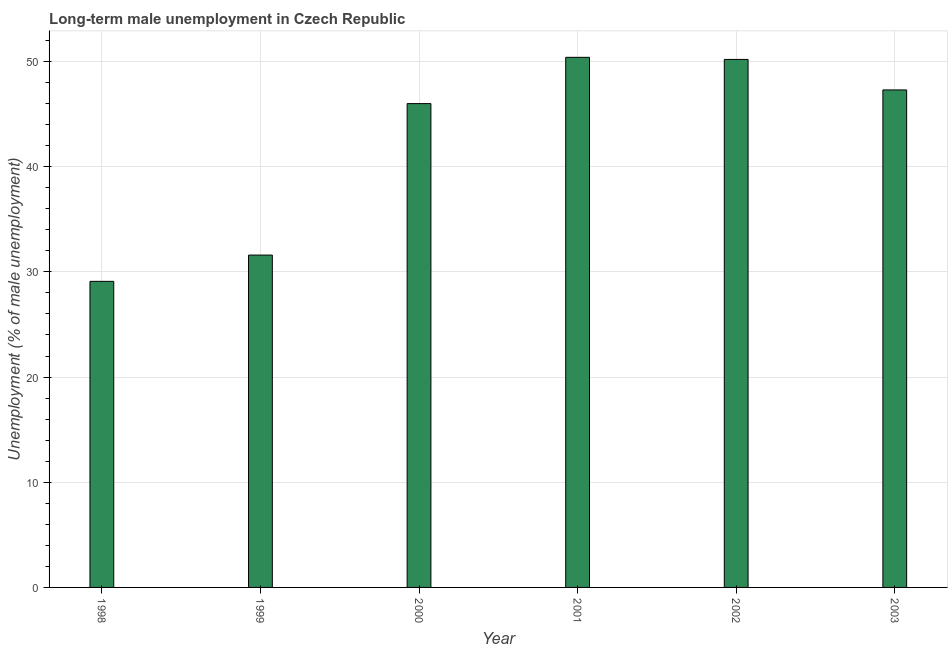Does the graph contain grids?
Your answer should be compact. Yes. What is the title of the graph?
Your answer should be very brief. Long-term male unemployment in Czech Republic. What is the label or title of the X-axis?
Keep it short and to the point. Year. What is the label or title of the Y-axis?
Keep it short and to the point. Unemployment (% of male unemployment). What is the long-term male unemployment in 2003?
Provide a short and direct response. 47.3. Across all years, what is the maximum long-term male unemployment?
Provide a succinct answer. 50.4. Across all years, what is the minimum long-term male unemployment?
Your answer should be compact. 29.1. What is the sum of the long-term male unemployment?
Make the answer very short. 254.6. What is the difference between the long-term male unemployment in 1999 and 2001?
Provide a short and direct response. -18.8. What is the average long-term male unemployment per year?
Make the answer very short. 42.43. What is the median long-term male unemployment?
Keep it short and to the point. 46.65. What is the ratio of the long-term male unemployment in 1998 to that in 2000?
Your response must be concise. 0.63. Is the long-term male unemployment in 1998 less than that in 2003?
Your response must be concise. Yes. Is the difference between the long-term male unemployment in 1998 and 2003 greater than the difference between any two years?
Give a very brief answer. No. What is the difference between the highest and the lowest long-term male unemployment?
Provide a succinct answer. 21.3. In how many years, is the long-term male unemployment greater than the average long-term male unemployment taken over all years?
Offer a terse response. 4. How many years are there in the graph?
Your answer should be compact. 6. What is the Unemployment (% of male unemployment) in 1998?
Offer a terse response. 29.1. What is the Unemployment (% of male unemployment) of 1999?
Ensure brevity in your answer.  31.6. What is the Unemployment (% of male unemployment) in 2000?
Make the answer very short. 46. What is the Unemployment (% of male unemployment) of 2001?
Offer a terse response. 50.4. What is the Unemployment (% of male unemployment) of 2002?
Your response must be concise. 50.2. What is the Unemployment (% of male unemployment) in 2003?
Provide a succinct answer. 47.3. What is the difference between the Unemployment (% of male unemployment) in 1998 and 1999?
Give a very brief answer. -2.5. What is the difference between the Unemployment (% of male unemployment) in 1998 and 2000?
Your response must be concise. -16.9. What is the difference between the Unemployment (% of male unemployment) in 1998 and 2001?
Make the answer very short. -21.3. What is the difference between the Unemployment (% of male unemployment) in 1998 and 2002?
Ensure brevity in your answer.  -21.1. What is the difference between the Unemployment (% of male unemployment) in 1998 and 2003?
Make the answer very short. -18.2. What is the difference between the Unemployment (% of male unemployment) in 1999 and 2000?
Your answer should be compact. -14.4. What is the difference between the Unemployment (% of male unemployment) in 1999 and 2001?
Ensure brevity in your answer.  -18.8. What is the difference between the Unemployment (% of male unemployment) in 1999 and 2002?
Your answer should be very brief. -18.6. What is the difference between the Unemployment (% of male unemployment) in 1999 and 2003?
Your answer should be very brief. -15.7. What is the ratio of the Unemployment (% of male unemployment) in 1998 to that in 1999?
Provide a succinct answer. 0.92. What is the ratio of the Unemployment (% of male unemployment) in 1998 to that in 2000?
Make the answer very short. 0.63. What is the ratio of the Unemployment (% of male unemployment) in 1998 to that in 2001?
Your response must be concise. 0.58. What is the ratio of the Unemployment (% of male unemployment) in 1998 to that in 2002?
Your answer should be compact. 0.58. What is the ratio of the Unemployment (% of male unemployment) in 1998 to that in 2003?
Keep it short and to the point. 0.61. What is the ratio of the Unemployment (% of male unemployment) in 1999 to that in 2000?
Ensure brevity in your answer.  0.69. What is the ratio of the Unemployment (% of male unemployment) in 1999 to that in 2001?
Your answer should be very brief. 0.63. What is the ratio of the Unemployment (% of male unemployment) in 1999 to that in 2002?
Your response must be concise. 0.63. What is the ratio of the Unemployment (% of male unemployment) in 1999 to that in 2003?
Provide a succinct answer. 0.67. What is the ratio of the Unemployment (% of male unemployment) in 2000 to that in 2002?
Keep it short and to the point. 0.92. What is the ratio of the Unemployment (% of male unemployment) in 2000 to that in 2003?
Offer a terse response. 0.97. What is the ratio of the Unemployment (% of male unemployment) in 2001 to that in 2002?
Give a very brief answer. 1. What is the ratio of the Unemployment (% of male unemployment) in 2001 to that in 2003?
Give a very brief answer. 1.07. What is the ratio of the Unemployment (% of male unemployment) in 2002 to that in 2003?
Keep it short and to the point. 1.06. 